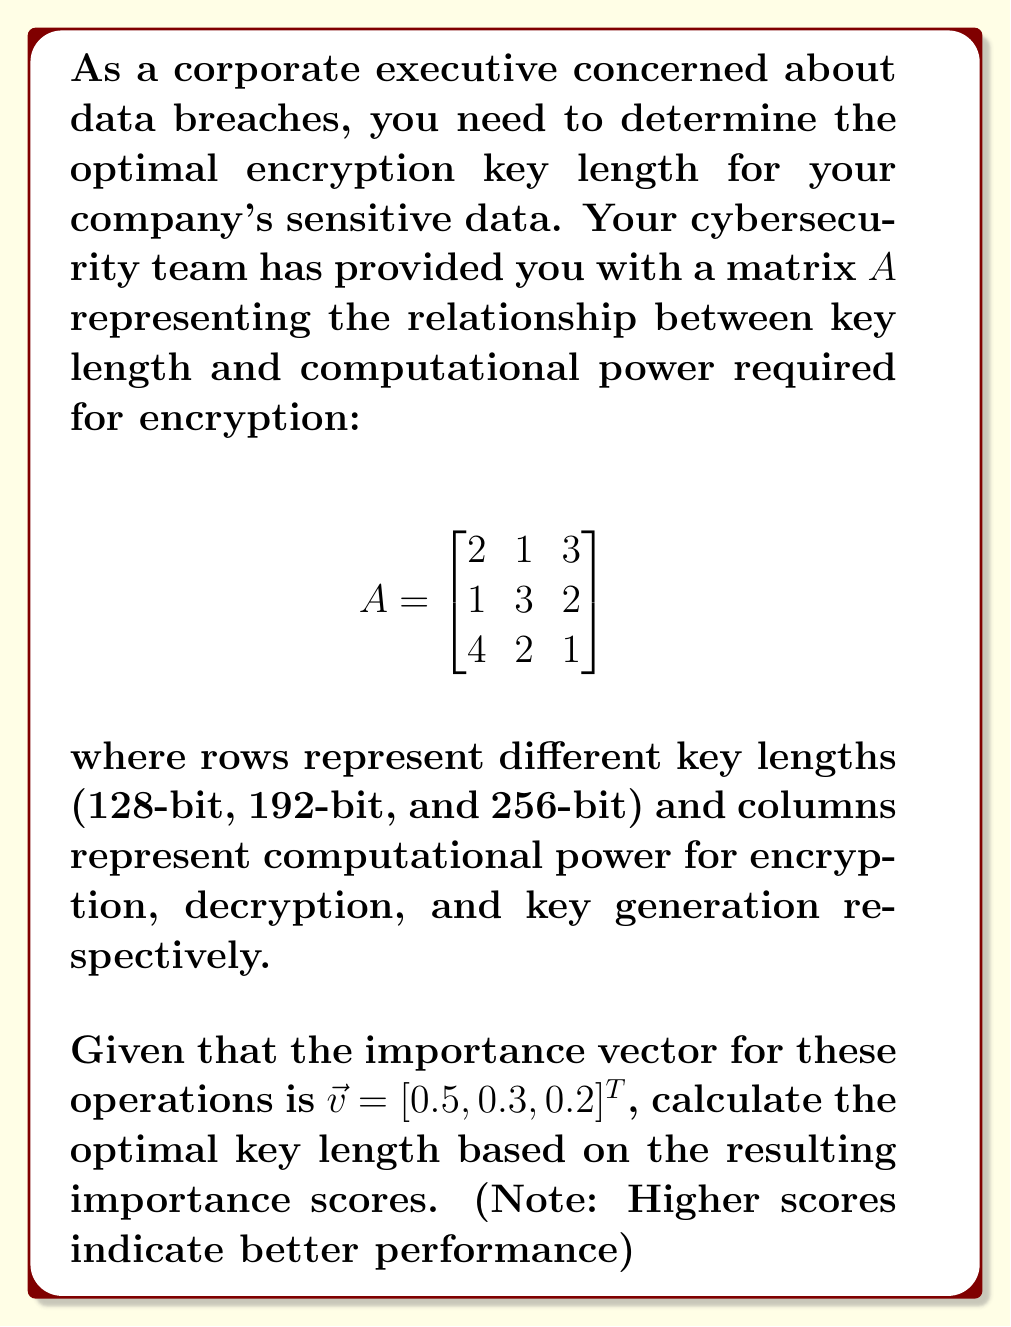Help me with this question. To solve this problem, we need to follow these steps:

1) First, we need to multiply the matrix $A$ by the importance vector $\vec{v}$. This will give us a vector of importance scores for each key length.

$$A\vec{v} = \begin{bmatrix}
2 & 1 & 3 \\
1 & 3 & 2 \\
4 & 2 & 1
\end{bmatrix} \begin{bmatrix}
0.5 \\
0.3 \\
0.2
\end{bmatrix}$$

2) Let's perform this matrix multiplication:

For 128-bit: $(2 \times 0.5) + (1 \times 0.3) + (3 \times 0.2) = 1 + 0.3 + 0.6 = 1.9$

For 192-bit: $(1 \times 0.5) + (3 \times 0.3) + (2 \times 0.2) = 0.5 + 0.9 + 0.4 = 1.8$

For 256-bit: $(4 \times 0.5) + (2 \times 0.3) + (1 \times 0.2) = 2 + 0.6 + 0.2 = 2.8$

3) The resulting vector of importance scores is:

$$A\vec{v} = \begin{bmatrix}
1.9 \\
1.8 \\
2.8
\end{bmatrix}$$

4) The highest score corresponds to the optimal key length. In this case, the highest score is 2.8, which corresponds to the 256-bit key length.

Therefore, based on this analysis, the optimal encryption key length for your company's sensitive data is 256-bit.
Answer: The optimal encryption key length is 256-bit, with an importance score of 2.8. 